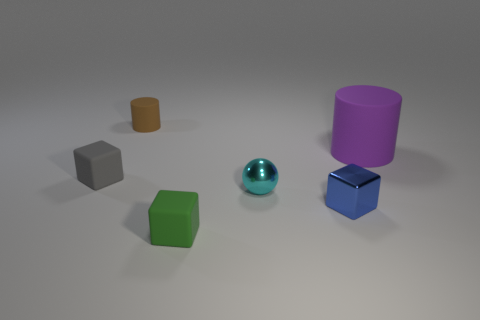Add 1 blue metallic things. How many objects exist? 7 Subtract all cylinders. How many objects are left? 4 Add 5 red blocks. How many red blocks exist? 5 Subtract 0 green balls. How many objects are left? 6 Subtract all purple objects. Subtract all purple matte things. How many objects are left? 4 Add 4 rubber cubes. How many rubber cubes are left? 6 